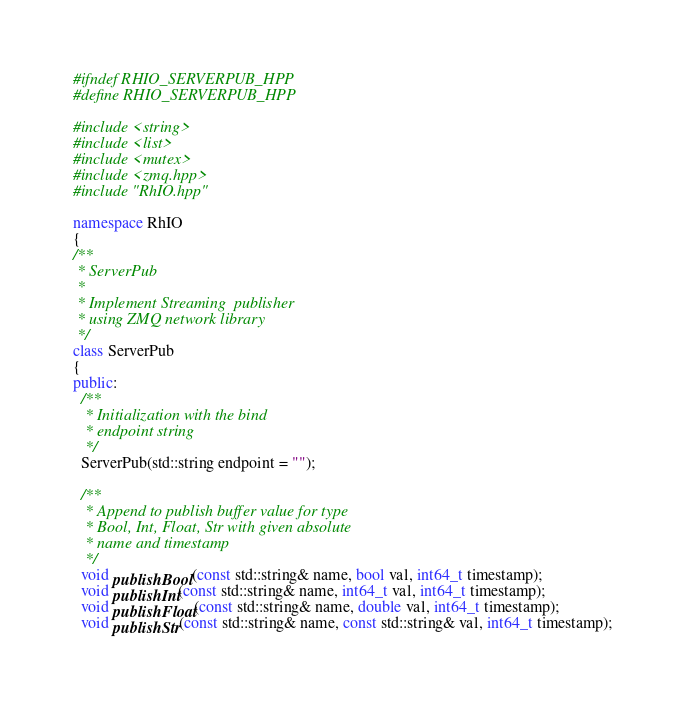<code> <loc_0><loc_0><loc_500><loc_500><_C++_>#ifndef RHIO_SERVERPUB_HPP
#define RHIO_SERVERPUB_HPP

#include <string>
#include <list>
#include <mutex>
#include <zmq.hpp>
#include "RhIO.hpp"

namespace RhIO
{
/**
 * ServerPub
 *
 * Implement Streaming  publisher
 * using ZMQ network library
 */
class ServerPub
{
public:
  /**
   * Initialization with the bind
   * endpoint string
   */
  ServerPub(std::string endpoint = "");

  /**
   * Append to publish buffer value for type
   * Bool, Int, Float, Str with given absolute
   * name and timestamp
   */
  void publishBool(const std::string& name, bool val, int64_t timestamp);
  void publishInt(const std::string& name, int64_t val, int64_t timestamp);
  void publishFloat(const std::string& name, double val, int64_t timestamp);
  void publishStr(const std::string& name, const std::string& val, int64_t timestamp);
</code> 